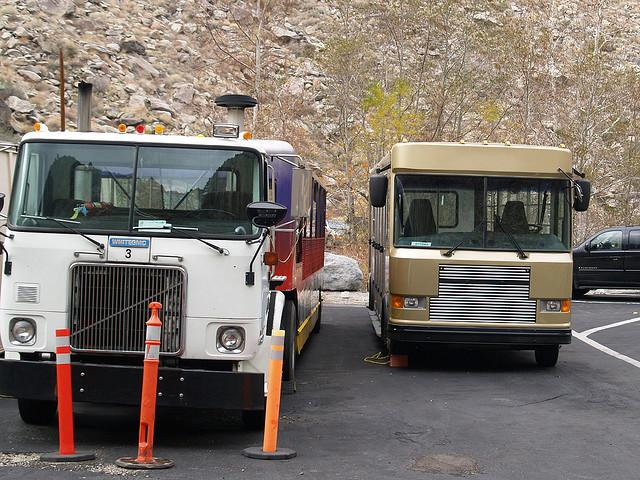What are these vehicles called? Please explain your reasoning. buses. The vehicles have many seats for holding passengers. 